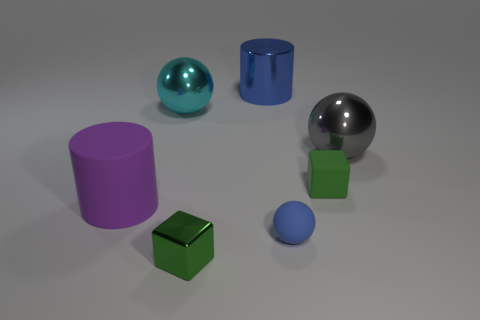Are there more purple matte cylinders in front of the small blue ball than large rubber cylinders?
Ensure brevity in your answer.  No. There is a blue object that is made of the same material as the large gray sphere; what is its shape?
Your answer should be compact. Cylinder. There is a cylinder that is in front of the blue metallic object; is it the same size as the gray sphere?
Give a very brief answer. Yes. The blue object behind the metal thing that is on the right side of the big metal cylinder is what shape?
Give a very brief answer. Cylinder. How big is the shiny ball left of the green cube that is left of the small green rubber thing?
Provide a short and direct response. Large. There is a cylinder behind the large gray metallic object; what color is it?
Offer a very short reply. Blue. There is a green object that is the same material as the large blue cylinder; what is its size?
Make the answer very short. Small. How many gray things have the same shape as the big blue thing?
Give a very brief answer. 0. There is a cyan ball that is the same size as the purple rubber cylinder; what material is it?
Offer a very short reply. Metal. Are there any tiny red cylinders made of the same material as the large purple thing?
Give a very brief answer. No. 